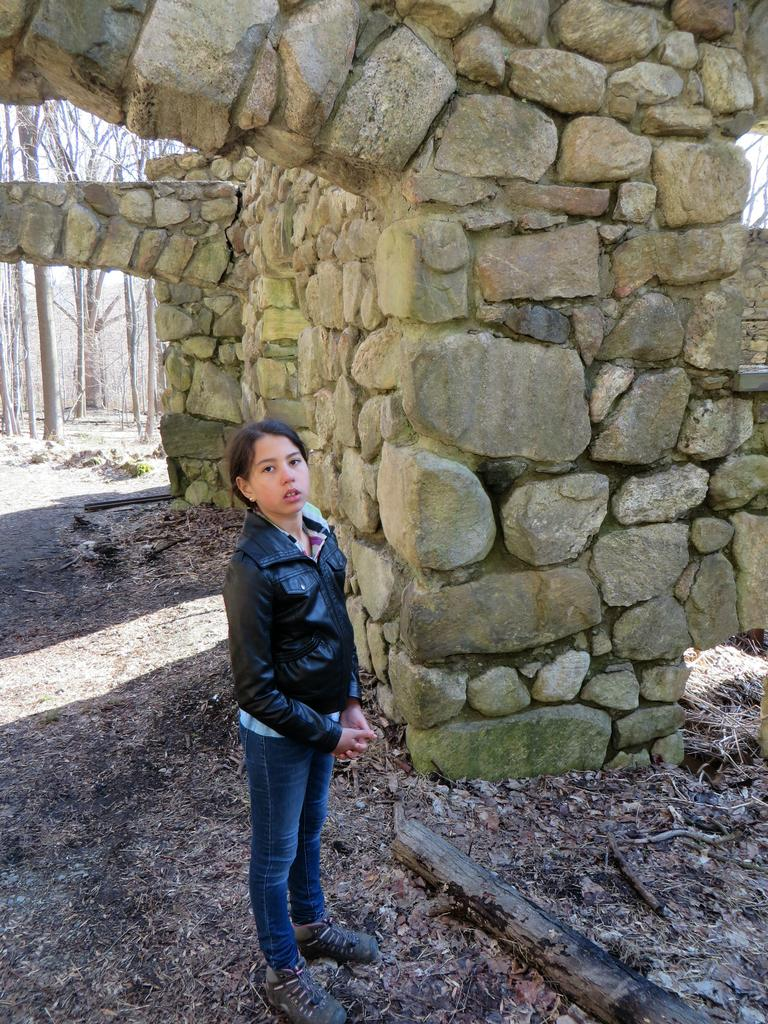What is the main subject of the image? The main subject of the image is a kid. What is the kid wearing? The kid is wearing clothes. Where is the kid standing in relation to the arches? The kid is standing beside an arch, and there is another arch in the image. What type of vegetation can be seen in the image? Trees are visible in the top left of the image. What type of camera is the kid holding in the image? There is no camera visible in the image; the kid is not holding any object. 